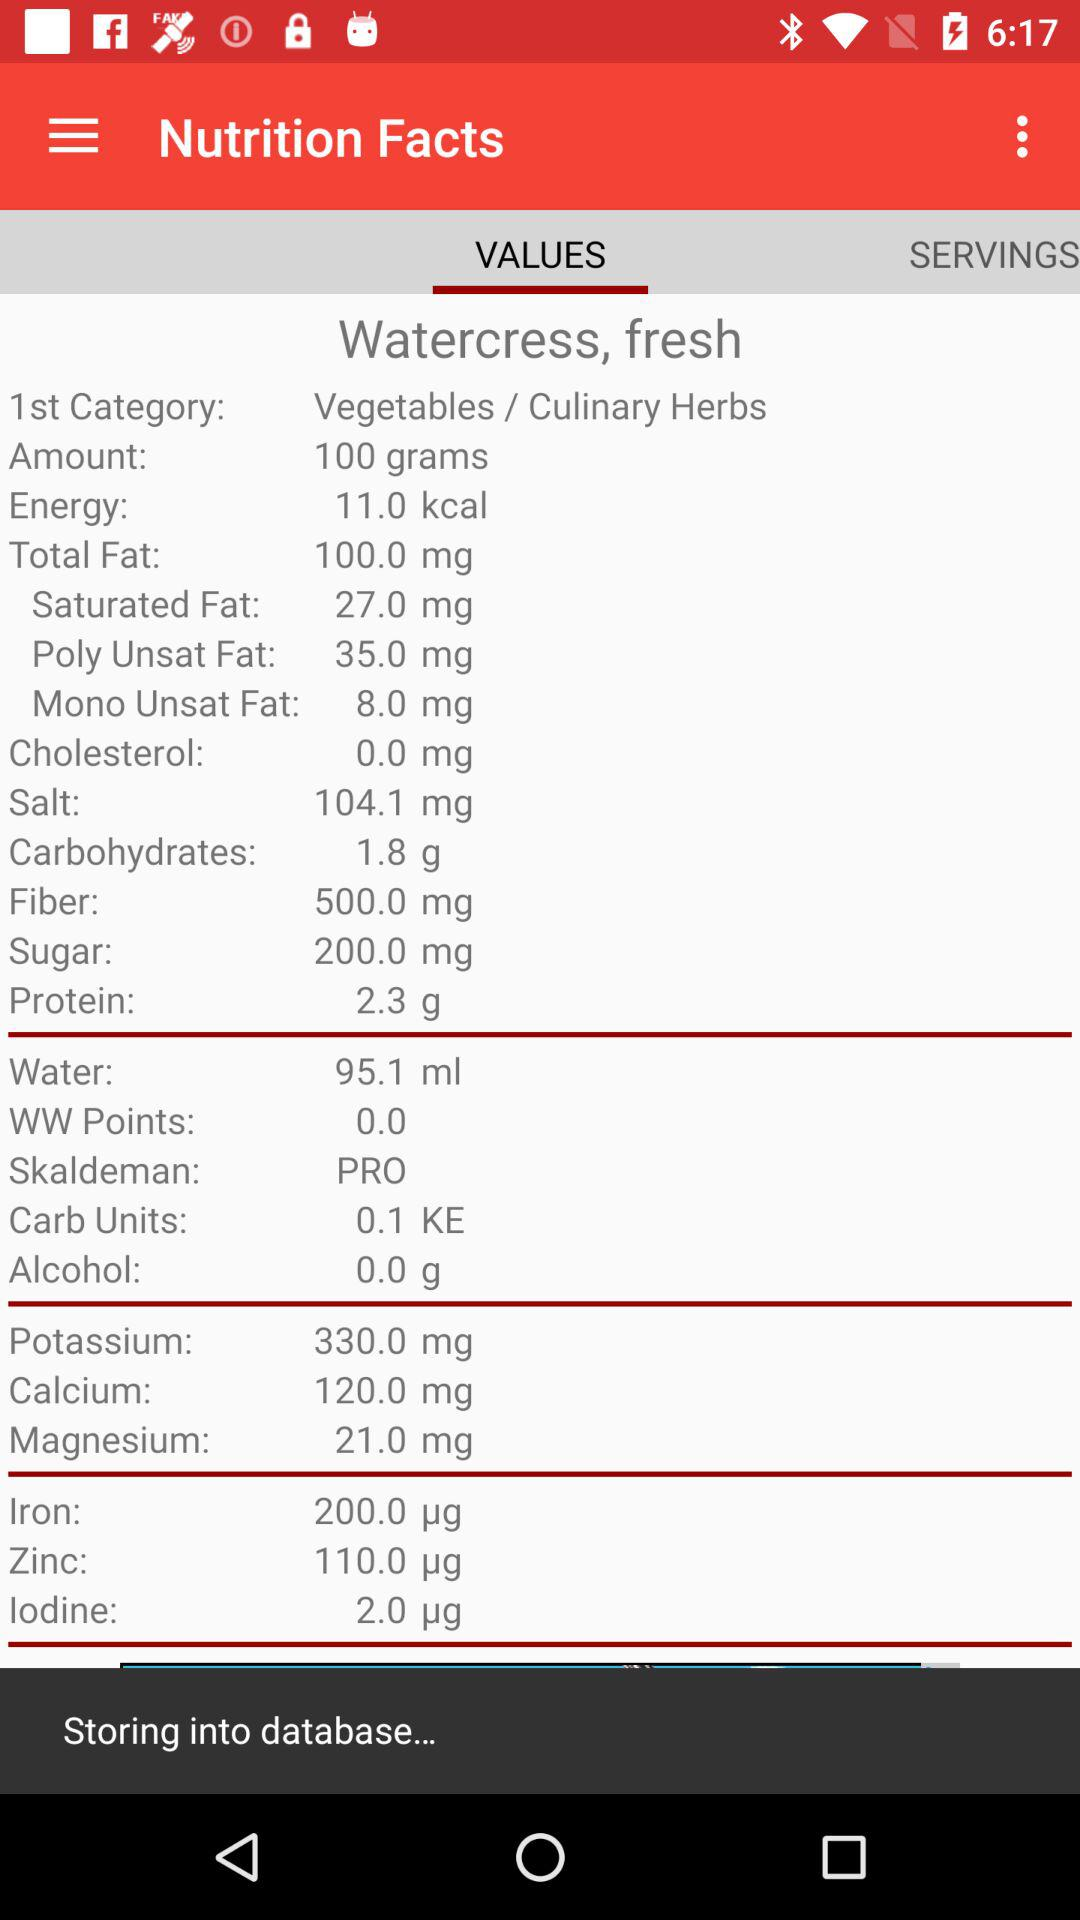How much water does the watercress contain? The watercress contains 95.1 ml of water. 